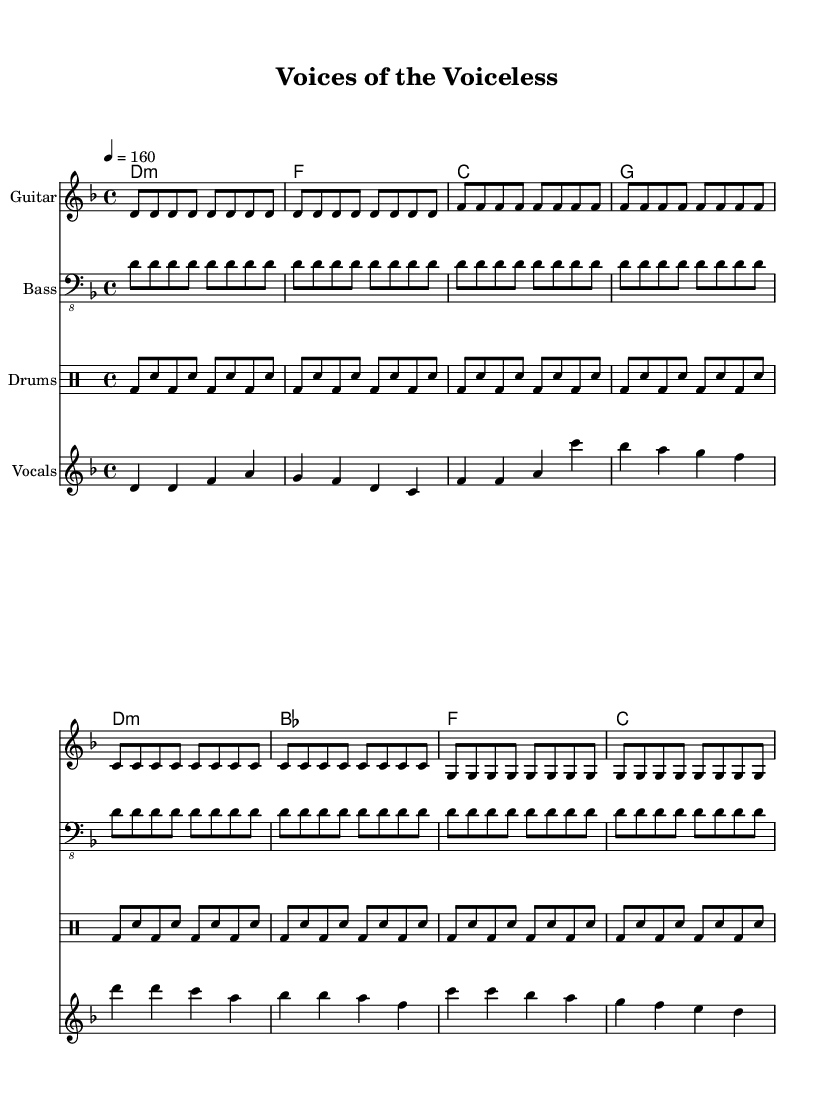What is the key signature of this music? The key signature is D minor, which contains one flat (B flat). This can be identified by looking at the beginning of the staff where the key signature notations are placed.
Answer: D minor What is the time signature of this piece? The time signature displayed at the beginning of the sheet music is 4/4, indicating that each measure contains four beats and a quarter note receives one beat. This is directly visible next to the key signature.
Answer: 4/4 What is the tempo marking for this piece? The tempo marking indicates that the piece should be played at a speed of 160 beats per minute. This is stated as "4 = 160" in the tempo indication, showing the correlation between the beat note and tempo.
Answer: 160 How many measures are in the guitar music section? The guitar music section consists of 16 measures, which can be counted by looking at the separation between musical phrases, as each line generally represents a group of 4 measures, amounting to 4 lines in total.
Answer: 16 What is the main thematic focus of the lyrics? The lyrics emphasize education as a tool for resistance and the need for grassroots activism, which is typical of the anarcho-punk genre, as inferred by phrases like “education is our weapon.” This can be observed in the lyrics provided.
Answer: Grassroots activism How does the drum pattern contribute to the overall feel of the song? The consistent bass drum and snare pattern create an energetic and driving background that complements the fast-paced tempo of the song. This combination is common in punk music to energize and motivate listeners.
Answer: Energetic What is the vocal range indicated in the melody section? The melody section spans from D to C, indicating that the vocal range is primarily centered around these pitches. It is visible by observing the lowest and highest notes in the melody line throughout the score.
Answer: D to C 